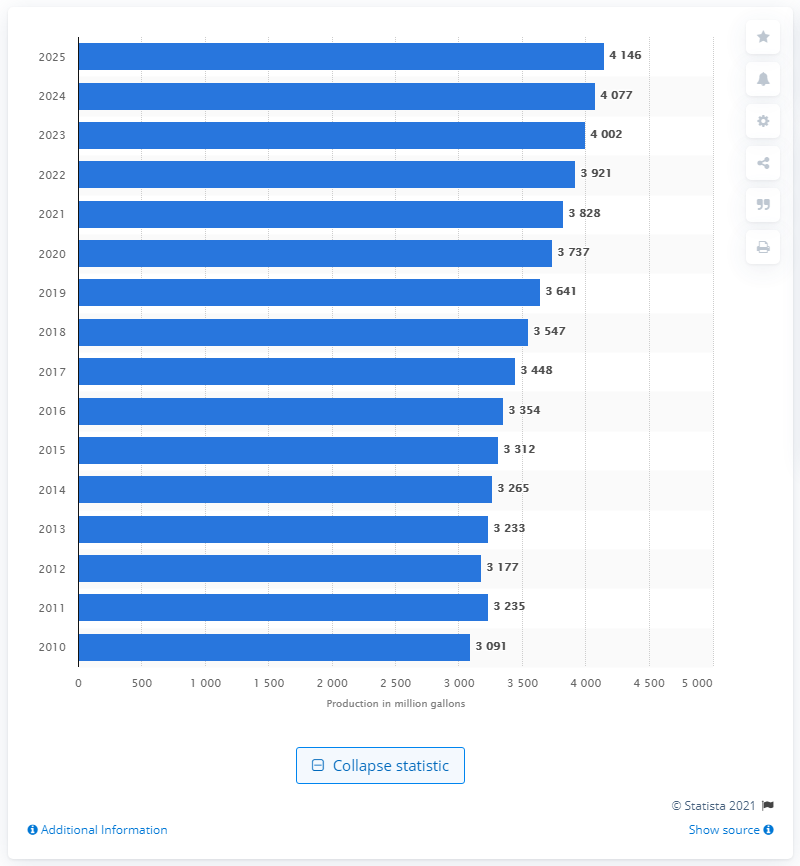Draw attention to some important aspects in this diagram. In 2015, the production of biodiesel in the EU was 3312 metric tons. 